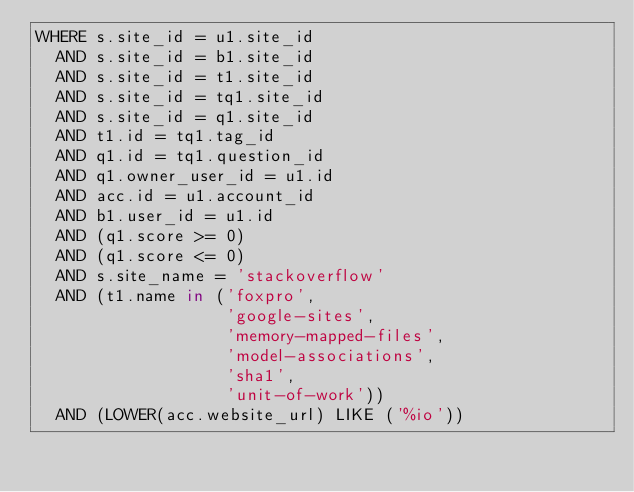Convert code to text. <code><loc_0><loc_0><loc_500><loc_500><_SQL_>WHERE s.site_id = u1.site_id
  AND s.site_id = b1.site_id
  AND s.site_id = t1.site_id
  AND s.site_id = tq1.site_id
  AND s.site_id = q1.site_id
  AND t1.id = tq1.tag_id
  AND q1.id = tq1.question_id
  AND q1.owner_user_id = u1.id
  AND acc.id = u1.account_id
  AND b1.user_id = u1.id
  AND (q1.score >= 0)
  AND (q1.score <= 0)
  AND s.site_name = 'stackoverflow'
  AND (t1.name in ('foxpro',
                   'google-sites',
                   'memory-mapped-files',
                   'model-associations',
                   'sha1',
                   'unit-of-work'))
  AND (LOWER(acc.website_url) LIKE ('%io'))</code> 